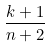Convert formula to latex. <formula><loc_0><loc_0><loc_500><loc_500>\frac { k + 1 } { n + 2 }</formula> 